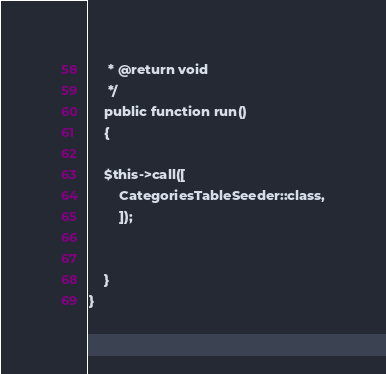Convert code to text. <code><loc_0><loc_0><loc_500><loc_500><_PHP_>     * @return void
     */
    public function run()
    {
      
    $this->call([
        CategoriesTableSeeder::class,
        ]);


    }
}
</code> 